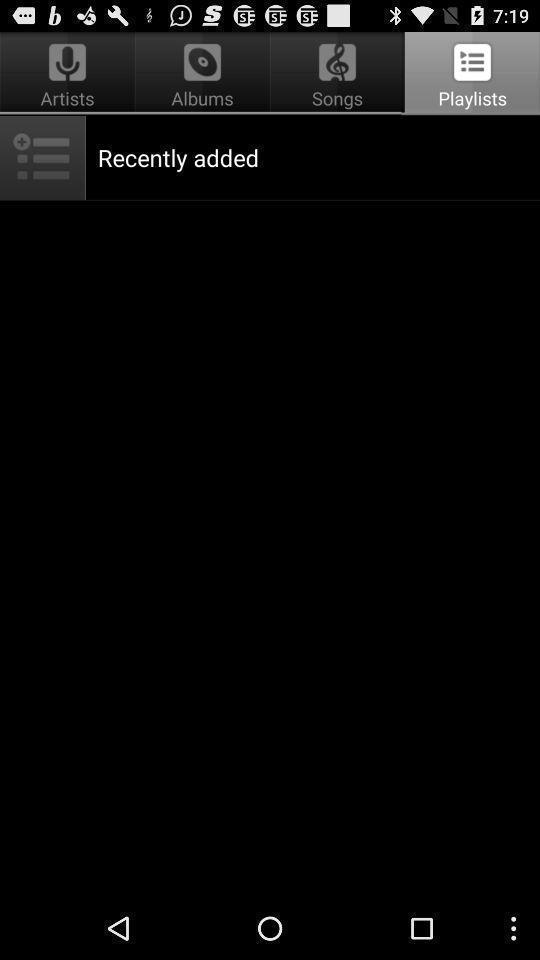Tell me about the visual elements in this screen capture. Screen shows about recently added playlists. 